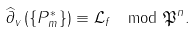<formula> <loc_0><loc_0><loc_500><loc_500>\widehat { \partial } _ { v } \left ( \{ P _ { m } ^ { * } \} \right ) \equiv \mathcal { L } _ { f } \mod \mathfrak { P } ^ { n } .</formula> 